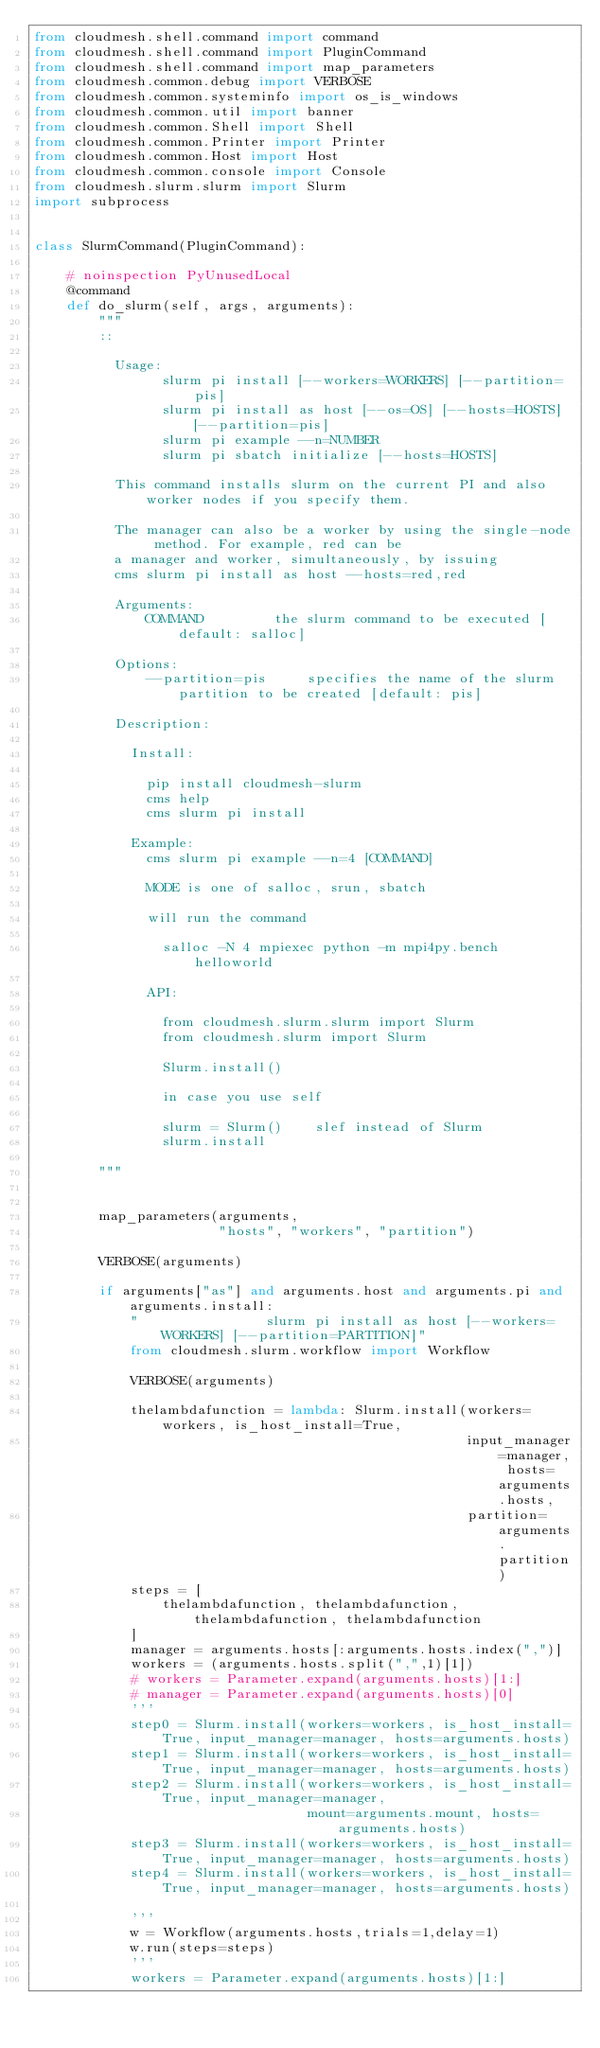Convert code to text. <code><loc_0><loc_0><loc_500><loc_500><_Python_>from cloudmesh.shell.command import command
from cloudmesh.shell.command import PluginCommand
from cloudmesh.shell.command import map_parameters
from cloudmesh.common.debug import VERBOSE
from cloudmesh.common.systeminfo import os_is_windows
from cloudmesh.common.util import banner
from cloudmesh.common.Shell import Shell
from cloudmesh.common.Printer import Printer
from cloudmesh.common.Host import Host
from cloudmesh.common.console import Console
from cloudmesh.slurm.slurm import Slurm
import subprocess


class SlurmCommand(PluginCommand):

    # noinspection PyUnusedLocal
    @command
    def do_slurm(self, args, arguments):
        """
        ::

          Usage:
                slurm pi install [--workers=WORKERS] [--partition=pis]
                slurm pi install as host [--os=OS] [--hosts=HOSTS] [--partition=pis]
                slurm pi example --n=NUMBER
                slurm pi sbatch initialize [--hosts=HOSTS]

          This command installs slurm on the current PI and also worker nodes if you specify them.

          The manager can also be a worker by using the single-node method. For example, red can be
          a manager and worker, simultaneously, by issuing
          cms slurm pi install as host --hosts=red,red

          Arguments:
              COMMAND         the slurm command to be executed [default: salloc]

          Options:
              --partition=pis     specifies the name of the slurm partition to be created [default: pis]

          Description:

            Install:

              pip install cloudmesh-slurm
              cms help
              cms slurm pi install

            Example:
              cms slurm pi example --n=4 [COMMAND]

              MODE is one of salloc, srun, sbatch

              will run the command

                salloc -N 4 mpiexec python -m mpi4py.bench helloworld

              API:

                from cloudmesh.slurm.slurm import Slurm
                from cloudmesh.slurm import Slurm

                Slurm.install()

                in case you use self

                slurm = Slurm()    slef instead of Slurm
                slurm.install

        """


        map_parameters(arguments,
                       "hosts", "workers", "partition")

        VERBOSE(arguments)

        if arguments["as"] and arguments.host and arguments.pi and arguments.install:
            "                slurm pi install as host [--workers=WORKERS] [--partition=PARTITION]"
            from cloudmesh.slurm.workflow import Workflow

            VERBOSE(arguments)

            thelambdafunction = lambda: Slurm.install(workers=workers, is_host_install=True,
                                                      input_manager=manager, hosts=arguments.hosts,
                                                      partition=arguments.partition)
            steps = [
                thelambdafunction, thelambdafunction, thelambdafunction, thelambdafunction
            ]
            manager = arguments.hosts[:arguments.hosts.index(",")]
            workers = (arguments.hosts.split(",",1)[1])
            # workers = Parameter.expand(arguments.hosts)[1:]
            # manager = Parameter.expand(arguments.hosts)[0]
            '''
            step0 = Slurm.install(workers=workers, is_host_install=True, input_manager=manager, hosts=arguments.hosts)
            step1 = Slurm.install(workers=workers, is_host_install=True, input_manager=manager, hosts=arguments.hosts)
            step2 = Slurm.install(workers=workers, is_host_install=True, input_manager=manager,
                                  mount=arguments.mount, hosts=arguments.hosts)
            step3 = Slurm.install(workers=workers, is_host_install=True, input_manager=manager, hosts=arguments.hosts)
            step4 = Slurm.install(workers=workers, is_host_install=True, input_manager=manager, hosts=arguments.hosts)

            '''
            w = Workflow(arguments.hosts,trials=1,delay=1)
            w.run(steps=steps)
            '''
            workers = Parameter.expand(arguments.hosts)[1:]</code> 